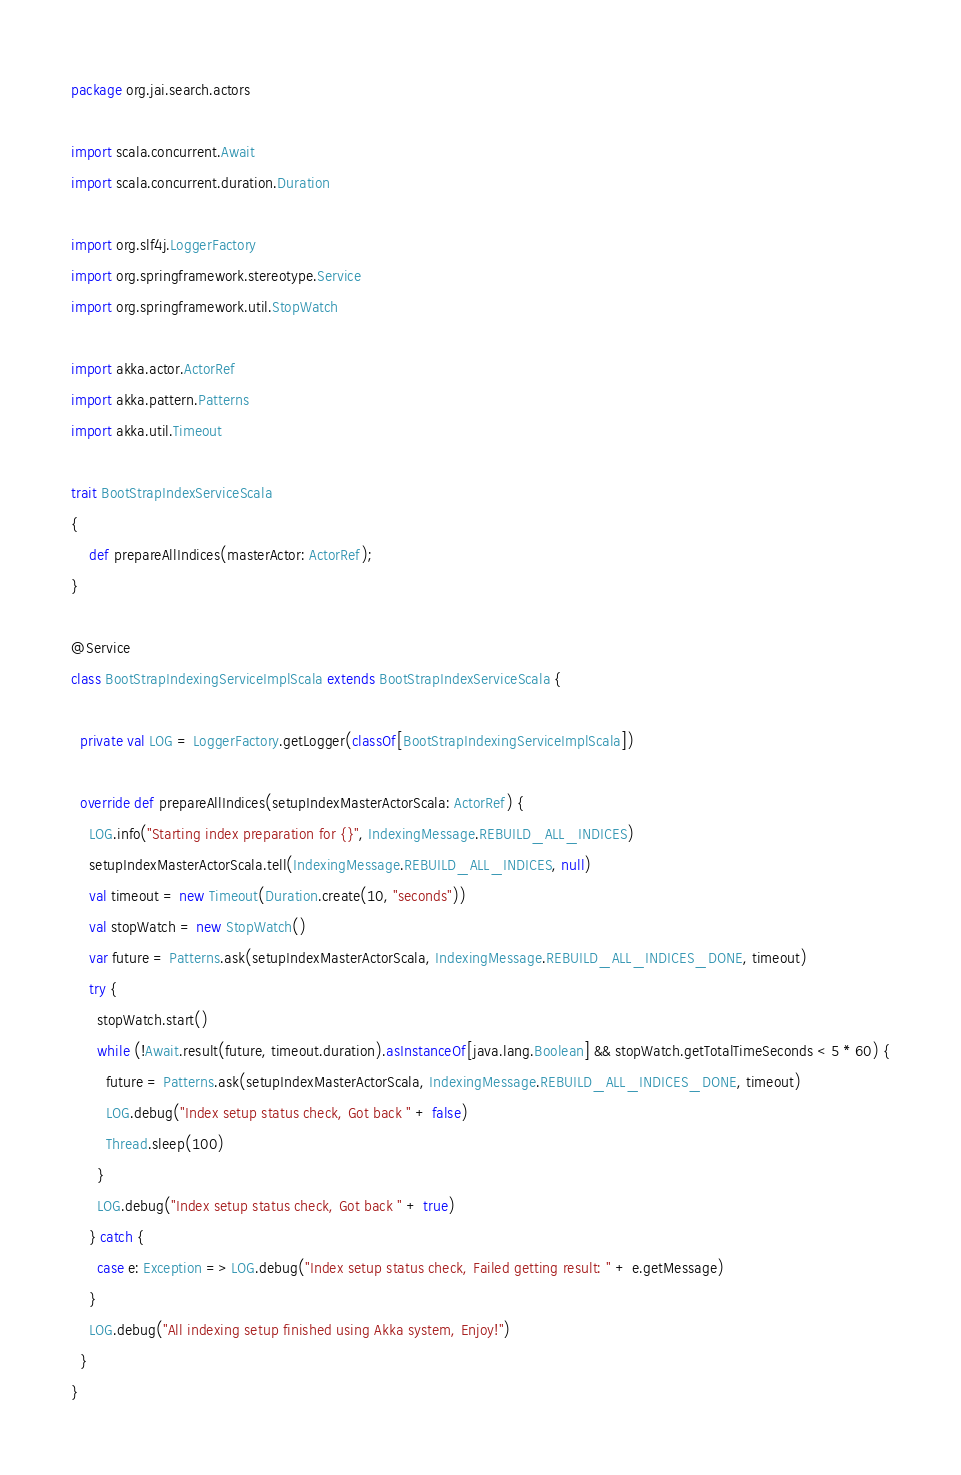Convert code to text. <code><loc_0><loc_0><loc_500><loc_500><_Scala_>package org.jai.search.actors

import scala.concurrent.Await
import scala.concurrent.duration.Duration

import org.slf4j.LoggerFactory
import org.springframework.stereotype.Service
import org.springframework.util.StopWatch

import akka.actor.ActorRef
import akka.pattern.Patterns
import akka.util.Timeout

trait BootStrapIndexServiceScala
{
    def prepareAllIndices(masterActor: ActorRef);
}

@Service
class BootStrapIndexingServiceImplScala extends BootStrapIndexServiceScala {

  private val LOG = LoggerFactory.getLogger(classOf[BootStrapIndexingServiceImplScala])

  override def prepareAllIndices(setupIndexMasterActorScala: ActorRef) {
    LOG.info("Starting index preparation for {}", IndexingMessage.REBUILD_ALL_INDICES)
    setupIndexMasterActorScala.tell(IndexingMessage.REBUILD_ALL_INDICES, null)
    val timeout = new Timeout(Duration.create(10, "seconds"))
    val stopWatch = new StopWatch()
    var future = Patterns.ask(setupIndexMasterActorScala, IndexingMessage.REBUILD_ALL_INDICES_DONE, timeout)
    try {
      stopWatch.start()
      while (!Await.result(future, timeout.duration).asInstanceOf[java.lang.Boolean] && stopWatch.getTotalTimeSeconds < 5 * 60) {
        future = Patterns.ask(setupIndexMasterActorScala, IndexingMessage.REBUILD_ALL_INDICES_DONE, timeout)
        LOG.debug("Index setup status check, Got back " + false)
        Thread.sleep(100)
      }
      LOG.debug("Index setup status check, Got back " + true)
    } catch {
      case e: Exception => LOG.debug("Index setup status check, Failed getting result: " + e.getMessage)
    }
    LOG.debug("All indexing setup finished using Akka system, Enjoy!")
  }
}
</code> 